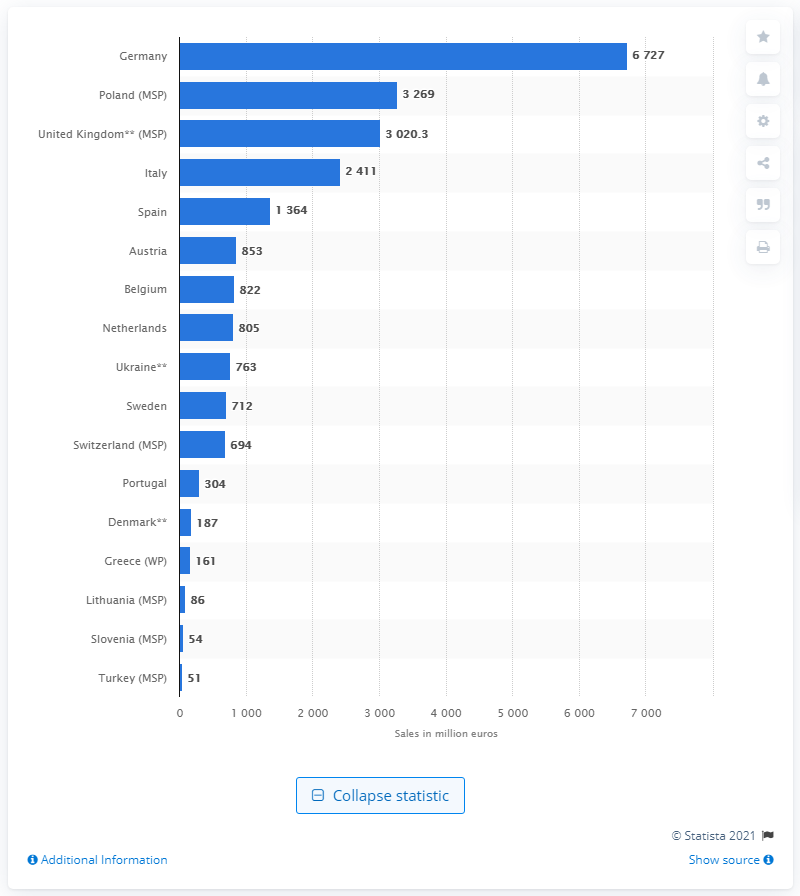Point out several critical features in this image. In 2017, the total value of non-prescription medicine sales in Germany was approximately 6,727. 